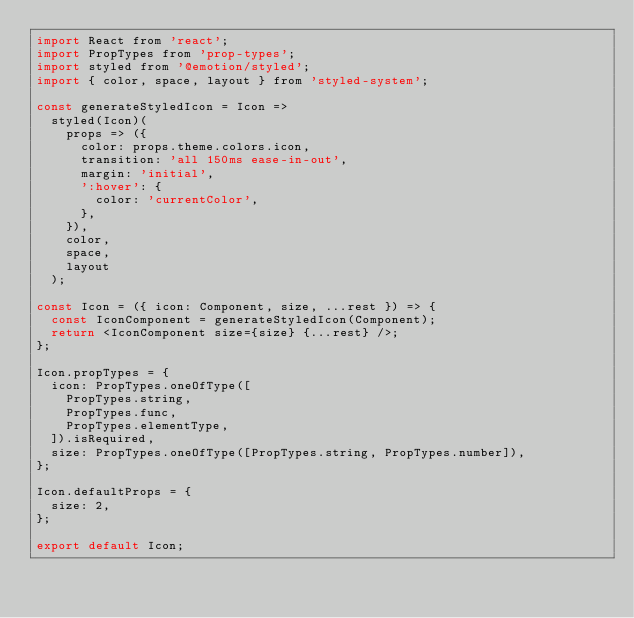<code> <loc_0><loc_0><loc_500><loc_500><_JavaScript_>import React from 'react';
import PropTypes from 'prop-types';
import styled from '@emotion/styled';
import { color, space, layout } from 'styled-system';

const generateStyledIcon = Icon =>
  styled(Icon)(
    props => ({
      color: props.theme.colors.icon,
      transition: 'all 150ms ease-in-out',
      margin: 'initial',
      ':hover': {
        color: 'currentColor',
      },
    }),
    color,
    space,
    layout
  );

const Icon = ({ icon: Component, size, ...rest }) => {
  const IconComponent = generateStyledIcon(Component);
  return <IconComponent size={size} {...rest} />;
};

Icon.propTypes = {
  icon: PropTypes.oneOfType([
    PropTypes.string,
    PropTypes.func,
    PropTypes.elementType,
  ]).isRequired,
  size: PropTypes.oneOfType([PropTypes.string, PropTypes.number]),
};

Icon.defaultProps = {
  size: 2,
};

export default Icon;
</code> 